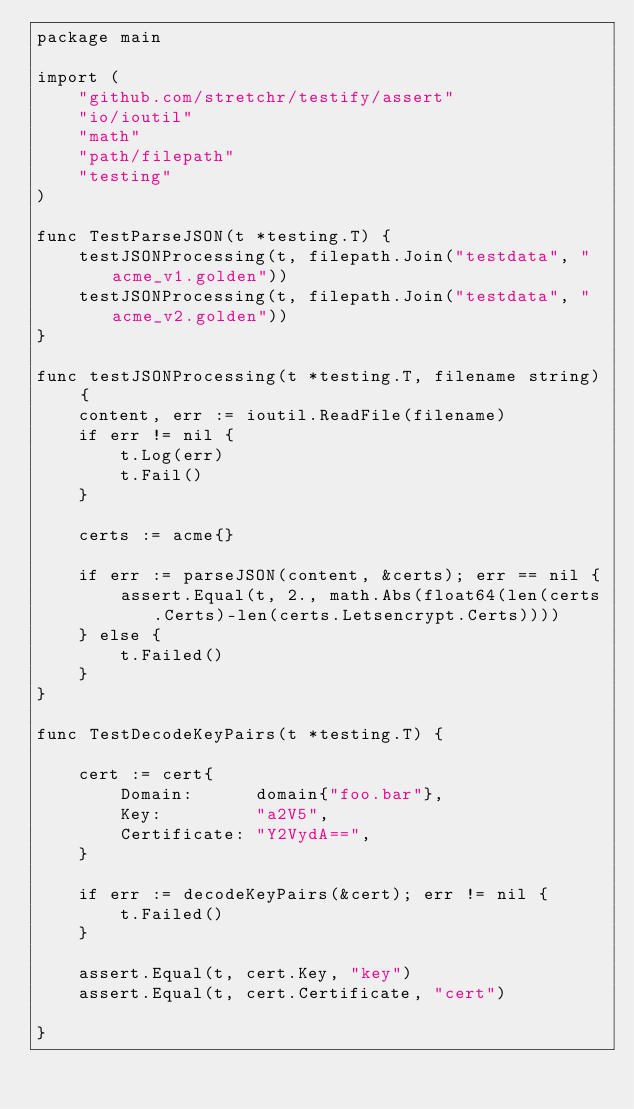<code> <loc_0><loc_0><loc_500><loc_500><_Go_>package main

import (
	"github.com/stretchr/testify/assert"
	"io/ioutil"
	"math"
	"path/filepath"
	"testing"
)

func TestParseJSON(t *testing.T) {
	testJSONProcessing(t, filepath.Join("testdata", "acme_v1.golden"))
	testJSONProcessing(t, filepath.Join("testdata", "acme_v2.golden"))
}

func testJSONProcessing(t *testing.T, filename string) {
	content, err := ioutil.ReadFile(filename)
	if err != nil {
		t.Log(err)
		t.Fail()
	}

	certs := acme{}

	if err := parseJSON(content, &certs); err == nil {
		assert.Equal(t, 2., math.Abs(float64(len(certs.Certs)-len(certs.Letsencrypt.Certs))))
	} else {
		t.Failed()
	}
}

func TestDecodeKeyPairs(t *testing.T) {

	cert := cert{
		Domain:      domain{"foo.bar"},
		Key:         "a2V5",
		Certificate: "Y2VydA==",
	}

	if err := decodeKeyPairs(&cert); err != nil {
		t.Failed()
	}

	assert.Equal(t, cert.Key, "key")
	assert.Equal(t, cert.Certificate, "cert")

}
</code> 